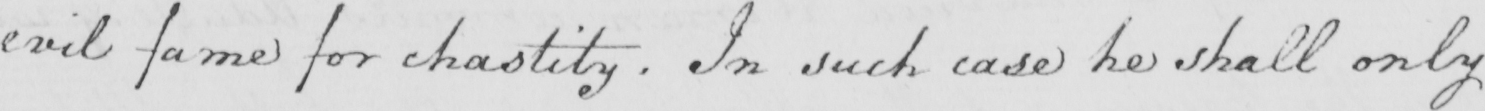Can you tell me what this handwritten text says? evil fame for chastity . In such case he shall only 